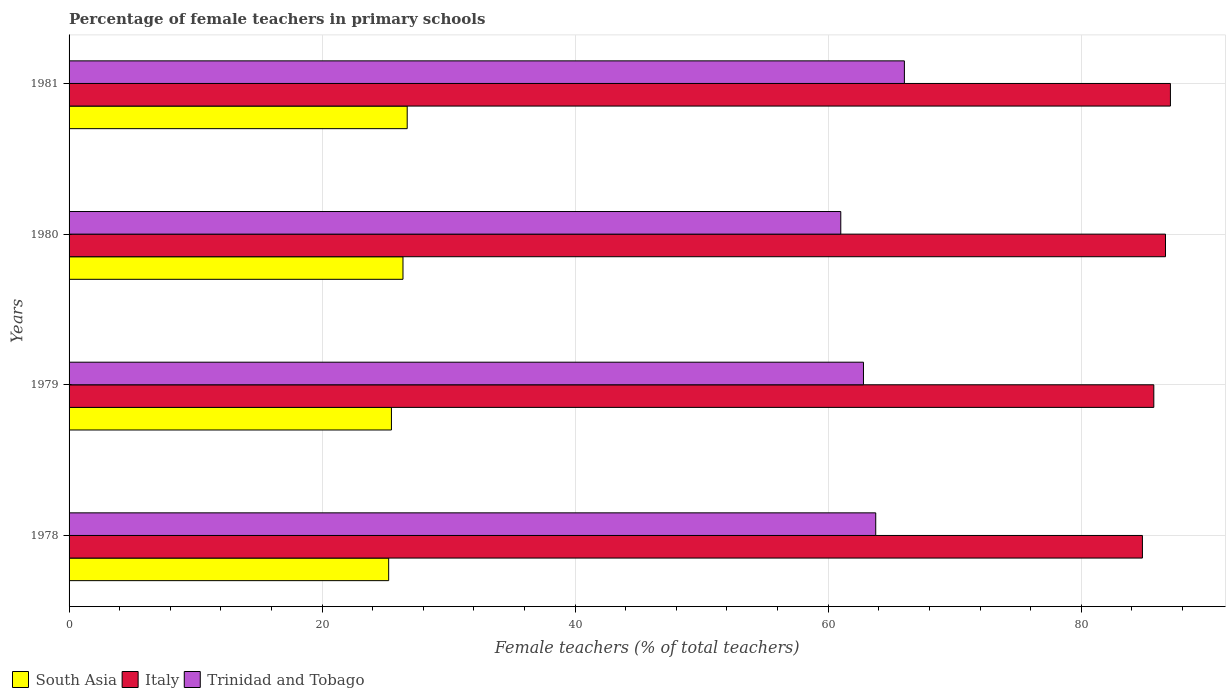How many bars are there on the 3rd tick from the top?
Your response must be concise. 3. How many bars are there on the 1st tick from the bottom?
Ensure brevity in your answer.  3. What is the label of the 4th group of bars from the top?
Your answer should be very brief. 1978. In how many cases, is the number of bars for a given year not equal to the number of legend labels?
Your response must be concise. 0. What is the percentage of female teachers in Italy in 1979?
Offer a very short reply. 85.74. Across all years, what is the maximum percentage of female teachers in South Asia?
Offer a very short reply. 26.73. Across all years, what is the minimum percentage of female teachers in Trinidad and Tobago?
Keep it short and to the point. 61. In which year was the percentage of female teachers in South Asia minimum?
Offer a terse response. 1978. What is the total percentage of female teachers in Italy in the graph?
Keep it short and to the point. 344.29. What is the difference between the percentage of female teachers in Trinidad and Tobago in 1978 and that in 1979?
Provide a succinct answer. 0.97. What is the difference between the percentage of female teachers in Trinidad and Tobago in 1981 and the percentage of female teachers in Italy in 1979?
Your response must be concise. -19.71. What is the average percentage of female teachers in Italy per year?
Keep it short and to the point. 86.07. In the year 1980, what is the difference between the percentage of female teachers in Italy and percentage of female teachers in South Asia?
Give a very brief answer. 60.27. In how many years, is the percentage of female teachers in South Asia greater than 76 %?
Ensure brevity in your answer.  0. What is the ratio of the percentage of female teachers in Trinidad and Tobago in 1978 to that in 1980?
Provide a succinct answer. 1.05. Is the difference between the percentage of female teachers in Italy in 1978 and 1981 greater than the difference between the percentage of female teachers in South Asia in 1978 and 1981?
Keep it short and to the point. No. What is the difference between the highest and the second highest percentage of female teachers in Italy?
Keep it short and to the point. 0.39. What is the difference between the highest and the lowest percentage of female teachers in South Asia?
Keep it short and to the point. 1.47. In how many years, is the percentage of female teachers in Trinidad and Tobago greater than the average percentage of female teachers in Trinidad and Tobago taken over all years?
Your answer should be very brief. 2. What does the 1st bar from the bottom in 1979 represents?
Your response must be concise. South Asia. Is it the case that in every year, the sum of the percentage of female teachers in Italy and percentage of female teachers in Trinidad and Tobago is greater than the percentage of female teachers in South Asia?
Offer a terse response. Yes. How many bars are there?
Offer a very short reply. 12. How many years are there in the graph?
Your answer should be compact. 4. How are the legend labels stacked?
Give a very brief answer. Horizontal. What is the title of the graph?
Ensure brevity in your answer.  Percentage of female teachers in primary schools. What is the label or title of the X-axis?
Your answer should be compact. Female teachers (% of total teachers). What is the label or title of the Y-axis?
Give a very brief answer. Years. What is the Female teachers (% of total teachers) in South Asia in 1978?
Offer a terse response. 25.26. What is the Female teachers (% of total teachers) of Italy in 1978?
Ensure brevity in your answer.  84.84. What is the Female teachers (% of total teachers) in Trinidad and Tobago in 1978?
Offer a very short reply. 63.76. What is the Female teachers (% of total teachers) of South Asia in 1979?
Your answer should be compact. 25.48. What is the Female teachers (% of total teachers) in Italy in 1979?
Ensure brevity in your answer.  85.74. What is the Female teachers (% of total teachers) in Trinidad and Tobago in 1979?
Make the answer very short. 62.79. What is the Female teachers (% of total teachers) of South Asia in 1980?
Keep it short and to the point. 26.39. What is the Female teachers (% of total teachers) in Italy in 1980?
Provide a short and direct response. 86.66. What is the Female teachers (% of total teachers) in Trinidad and Tobago in 1980?
Make the answer very short. 61. What is the Female teachers (% of total teachers) of South Asia in 1981?
Offer a very short reply. 26.73. What is the Female teachers (% of total teachers) in Italy in 1981?
Your answer should be compact. 87.05. What is the Female teachers (% of total teachers) in Trinidad and Tobago in 1981?
Your answer should be very brief. 66.02. Across all years, what is the maximum Female teachers (% of total teachers) in South Asia?
Offer a terse response. 26.73. Across all years, what is the maximum Female teachers (% of total teachers) of Italy?
Provide a succinct answer. 87.05. Across all years, what is the maximum Female teachers (% of total teachers) of Trinidad and Tobago?
Your answer should be compact. 66.02. Across all years, what is the minimum Female teachers (% of total teachers) of South Asia?
Offer a terse response. 25.26. Across all years, what is the minimum Female teachers (% of total teachers) of Italy?
Offer a terse response. 84.84. Across all years, what is the minimum Female teachers (% of total teachers) in Trinidad and Tobago?
Your answer should be compact. 61. What is the total Female teachers (% of total teachers) of South Asia in the graph?
Make the answer very short. 103.86. What is the total Female teachers (% of total teachers) in Italy in the graph?
Your response must be concise. 344.29. What is the total Female teachers (% of total teachers) in Trinidad and Tobago in the graph?
Give a very brief answer. 253.57. What is the difference between the Female teachers (% of total teachers) in South Asia in 1978 and that in 1979?
Your answer should be very brief. -0.22. What is the difference between the Female teachers (% of total teachers) in Italy in 1978 and that in 1979?
Offer a very short reply. -0.9. What is the difference between the Female teachers (% of total teachers) in Trinidad and Tobago in 1978 and that in 1979?
Provide a succinct answer. 0.97. What is the difference between the Female teachers (% of total teachers) in South Asia in 1978 and that in 1980?
Make the answer very short. -1.13. What is the difference between the Female teachers (% of total teachers) of Italy in 1978 and that in 1980?
Your answer should be very brief. -1.82. What is the difference between the Female teachers (% of total teachers) of Trinidad and Tobago in 1978 and that in 1980?
Your response must be concise. 2.76. What is the difference between the Female teachers (% of total teachers) of South Asia in 1978 and that in 1981?
Give a very brief answer. -1.47. What is the difference between the Female teachers (% of total teachers) of Italy in 1978 and that in 1981?
Offer a very short reply. -2.21. What is the difference between the Female teachers (% of total teachers) in Trinidad and Tobago in 1978 and that in 1981?
Offer a very short reply. -2.26. What is the difference between the Female teachers (% of total teachers) in South Asia in 1979 and that in 1980?
Offer a terse response. -0.91. What is the difference between the Female teachers (% of total teachers) in Italy in 1979 and that in 1980?
Ensure brevity in your answer.  -0.92. What is the difference between the Female teachers (% of total teachers) in Trinidad and Tobago in 1979 and that in 1980?
Make the answer very short. 1.79. What is the difference between the Female teachers (% of total teachers) in South Asia in 1979 and that in 1981?
Offer a very short reply. -1.25. What is the difference between the Female teachers (% of total teachers) in Italy in 1979 and that in 1981?
Provide a succinct answer. -1.31. What is the difference between the Female teachers (% of total teachers) in Trinidad and Tobago in 1979 and that in 1981?
Ensure brevity in your answer.  -3.23. What is the difference between the Female teachers (% of total teachers) of South Asia in 1980 and that in 1981?
Ensure brevity in your answer.  -0.33. What is the difference between the Female teachers (% of total teachers) in Italy in 1980 and that in 1981?
Offer a very short reply. -0.39. What is the difference between the Female teachers (% of total teachers) in Trinidad and Tobago in 1980 and that in 1981?
Your response must be concise. -5.03. What is the difference between the Female teachers (% of total teachers) of South Asia in 1978 and the Female teachers (% of total teachers) of Italy in 1979?
Keep it short and to the point. -60.48. What is the difference between the Female teachers (% of total teachers) in South Asia in 1978 and the Female teachers (% of total teachers) in Trinidad and Tobago in 1979?
Offer a terse response. -37.53. What is the difference between the Female teachers (% of total teachers) in Italy in 1978 and the Female teachers (% of total teachers) in Trinidad and Tobago in 1979?
Make the answer very short. 22.05. What is the difference between the Female teachers (% of total teachers) in South Asia in 1978 and the Female teachers (% of total teachers) in Italy in 1980?
Offer a very short reply. -61.4. What is the difference between the Female teachers (% of total teachers) in South Asia in 1978 and the Female teachers (% of total teachers) in Trinidad and Tobago in 1980?
Ensure brevity in your answer.  -35.74. What is the difference between the Female teachers (% of total teachers) in Italy in 1978 and the Female teachers (% of total teachers) in Trinidad and Tobago in 1980?
Provide a short and direct response. 23.84. What is the difference between the Female teachers (% of total teachers) of South Asia in 1978 and the Female teachers (% of total teachers) of Italy in 1981?
Your response must be concise. -61.79. What is the difference between the Female teachers (% of total teachers) of South Asia in 1978 and the Female teachers (% of total teachers) of Trinidad and Tobago in 1981?
Your answer should be very brief. -40.76. What is the difference between the Female teachers (% of total teachers) in Italy in 1978 and the Female teachers (% of total teachers) in Trinidad and Tobago in 1981?
Offer a very short reply. 18.81. What is the difference between the Female teachers (% of total teachers) of South Asia in 1979 and the Female teachers (% of total teachers) of Italy in 1980?
Offer a terse response. -61.18. What is the difference between the Female teachers (% of total teachers) of South Asia in 1979 and the Female teachers (% of total teachers) of Trinidad and Tobago in 1980?
Your response must be concise. -35.52. What is the difference between the Female teachers (% of total teachers) in Italy in 1979 and the Female teachers (% of total teachers) in Trinidad and Tobago in 1980?
Make the answer very short. 24.74. What is the difference between the Female teachers (% of total teachers) in South Asia in 1979 and the Female teachers (% of total teachers) in Italy in 1981?
Your answer should be very brief. -61.57. What is the difference between the Female teachers (% of total teachers) of South Asia in 1979 and the Female teachers (% of total teachers) of Trinidad and Tobago in 1981?
Provide a succinct answer. -40.54. What is the difference between the Female teachers (% of total teachers) of Italy in 1979 and the Female teachers (% of total teachers) of Trinidad and Tobago in 1981?
Your answer should be very brief. 19.71. What is the difference between the Female teachers (% of total teachers) in South Asia in 1980 and the Female teachers (% of total teachers) in Italy in 1981?
Offer a very short reply. -60.66. What is the difference between the Female teachers (% of total teachers) in South Asia in 1980 and the Female teachers (% of total teachers) in Trinidad and Tobago in 1981?
Offer a terse response. -39.63. What is the difference between the Female teachers (% of total teachers) in Italy in 1980 and the Female teachers (% of total teachers) in Trinidad and Tobago in 1981?
Offer a very short reply. 20.64. What is the average Female teachers (% of total teachers) in South Asia per year?
Keep it short and to the point. 25.97. What is the average Female teachers (% of total teachers) in Italy per year?
Your response must be concise. 86.07. What is the average Female teachers (% of total teachers) of Trinidad and Tobago per year?
Make the answer very short. 63.39. In the year 1978, what is the difference between the Female teachers (% of total teachers) in South Asia and Female teachers (% of total teachers) in Italy?
Provide a succinct answer. -59.58. In the year 1978, what is the difference between the Female teachers (% of total teachers) of South Asia and Female teachers (% of total teachers) of Trinidad and Tobago?
Your response must be concise. -38.5. In the year 1978, what is the difference between the Female teachers (% of total teachers) in Italy and Female teachers (% of total teachers) in Trinidad and Tobago?
Make the answer very short. 21.08. In the year 1979, what is the difference between the Female teachers (% of total teachers) of South Asia and Female teachers (% of total teachers) of Italy?
Your answer should be very brief. -60.26. In the year 1979, what is the difference between the Female teachers (% of total teachers) of South Asia and Female teachers (% of total teachers) of Trinidad and Tobago?
Keep it short and to the point. -37.31. In the year 1979, what is the difference between the Female teachers (% of total teachers) in Italy and Female teachers (% of total teachers) in Trinidad and Tobago?
Keep it short and to the point. 22.95. In the year 1980, what is the difference between the Female teachers (% of total teachers) of South Asia and Female teachers (% of total teachers) of Italy?
Ensure brevity in your answer.  -60.27. In the year 1980, what is the difference between the Female teachers (% of total teachers) of South Asia and Female teachers (% of total teachers) of Trinidad and Tobago?
Your answer should be very brief. -34.6. In the year 1980, what is the difference between the Female teachers (% of total teachers) of Italy and Female teachers (% of total teachers) of Trinidad and Tobago?
Provide a short and direct response. 25.67. In the year 1981, what is the difference between the Female teachers (% of total teachers) in South Asia and Female teachers (% of total teachers) in Italy?
Your answer should be compact. -60.33. In the year 1981, what is the difference between the Female teachers (% of total teachers) in South Asia and Female teachers (% of total teachers) in Trinidad and Tobago?
Offer a terse response. -39.3. In the year 1981, what is the difference between the Female teachers (% of total teachers) of Italy and Female teachers (% of total teachers) of Trinidad and Tobago?
Give a very brief answer. 21.03. What is the ratio of the Female teachers (% of total teachers) of South Asia in 1978 to that in 1979?
Ensure brevity in your answer.  0.99. What is the ratio of the Female teachers (% of total teachers) of Trinidad and Tobago in 1978 to that in 1979?
Your response must be concise. 1.02. What is the ratio of the Female teachers (% of total teachers) in South Asia in 1978 to that in 1980?
Provide a succinct answer. 0.96. What is the ratio of the Female teachers (% of total teachers) of Italy in 1978 to that in 1980?
Keep it short and to the point. 0.98. What is the ratio of the Female teachers (% of total teachers) of Trinidad and Tobago in 1978 to that in 1980?
Provide a succinct answer. 1.05. What is the ratio of the Female teachers (% of total teachers) of South Asia in 1978 to that in 1981?
Your response must be concise. 0.95. What is the ratio of the Female teachers (% of total teachers) of Italy in 1978 to that in 1981?
Offer a very short reply. 0.97. What is the ratio of the Female teachers (% of total teachers) in Trinidad and Tobago in 1978 to that in 1981?
Offer a very short reply. 0.97. What is the ratio of the Female teachers (% of total teachers) in South Asia in 1979 to that in 1980?
Your response must be concise. 0.97. What is the ratio of the Female teachers (% of total teachers) in Italy in 1979 to that in 1980?
Provide a succinct answer. 0.99. What is the ratio of the Female teachers (% of total teachers) in Trinidad and Tobago in 1979 to that in 1980?
Provide a succinct answer. 1.03. What is the ratio of the Female teachers (% of total teachers) of South Asia in 1979 to that in 1981?
Provide a succinct answer. 0.95. What is the ratio of the Female teachers (% of total teachers) of Italy in 1979 to that in 1981?
Provide a succinct answer. 0.98. What is the ratio of the Female teachers (% of total teachers) in Trinidad and Tobago in 1979 to that in 1981?
Ensure brevity in your answer.  0.95. What is the ratio of the Female teachers (% of total teachers) of South Asia in 1980 to that in 1981?
Your answer should be very brief. 0.99. What is the ratio of the Female teachers (% of total teachers) of Italy in 1980 to that in 1981?
Your answer should be very brief. 1. What is the ratio of the Female teachers (% of total teachers) in Trinidad and Tobago in 1980 to that in 1981?
Give a very brief answer. 0.92. What is the difference between the highest and the second highest Female teachers (% of total teachers) in South Asia?
Keep it short and to the point. 0.33. What is the difference between the highest and the second highest Female teachers (% of total teachers) of Italy?
Your response must be concise. 0.39. What is the difference between the highest and the second highest Female teachers (% of total teachers) in Trinidad and Tobago?
Your answer should be compact. 2.26. What is the difference between the highest and the lowest Female teachers (% of total teachers) of South Asia?
Make the answer very short. 1.47. What is the difference between the highest and the lowest Female teachers (% of total teachers) in Italy?
Provide a short and direct response. 2.21. What is the difference between the highest and the lowest Female teachers (% of total teachers) of Trinidad and Tobago?
Your answer should be compact. 5.03. 